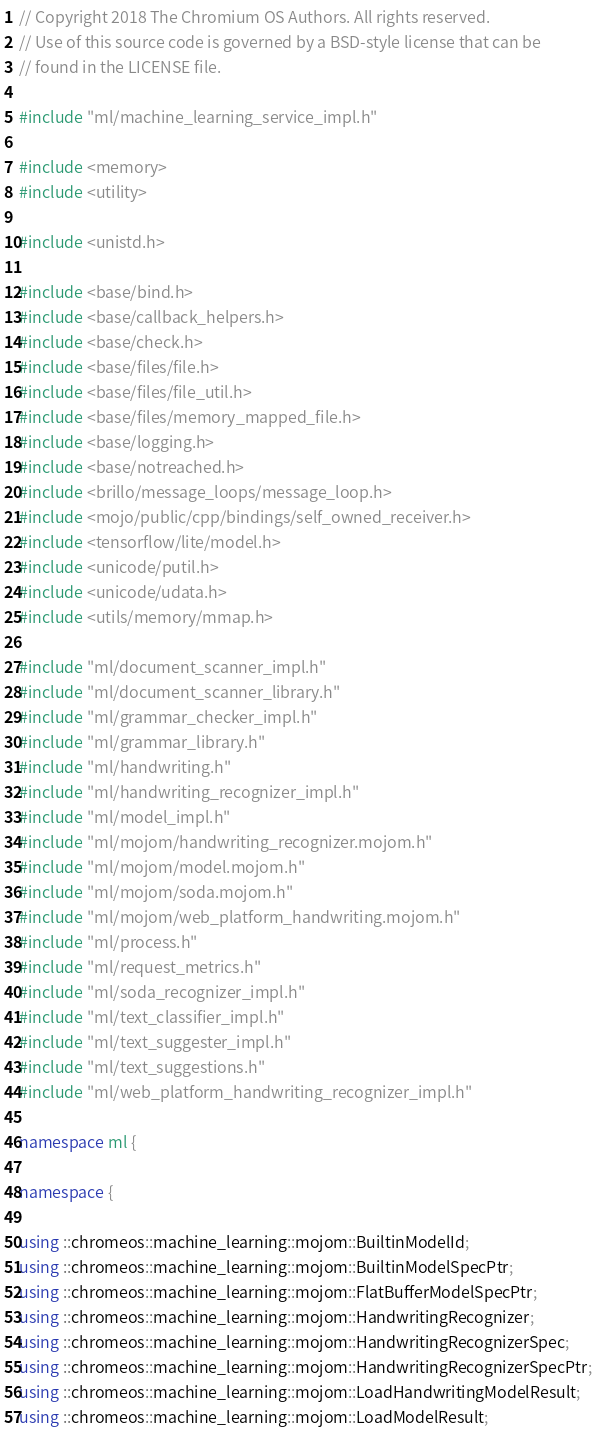Convert code to text. <code><loc_0><loc_0><loc_500><loc_500><_C++_>// Copyright 2018 The Chromium OS Authors. All rights reserved.
// Use of this source code is governed by a BSD-style license that can be
// found in the LICENSE file.

#include "ml/machine_learning_service_impl.h"

#include <memory>
#include <utility>

#include <unistd.h>

#include <base/bind.h>
#include <base/callback_helpers.h>
#include <base/check.h>
#include <base/files/file.h>
#include <base/files/file_util.h>
#include <base/files/memory_mapped_file.h>
#include <base/logging.h>
#include <base/notreached.h>
#include <brillo/message_loops/message_loop.h>
#include <mojo/public/cpp/bindings/self_owned_receiver.h>
#include <tensorflow/lite/model.h>
#include <unicode/putil.h>
#include <unicode/udata.h>
#include <utils/memory/mmap.h>

#include "ml/document_scanner_impl.h"
#include "ml/document_scanner_library.h"
#include "ml/grammar_checker_impl.h"
#include "ml/grammar_library.h"
#include "ml/handwriting.h"
#include "ml/handwriting_recognizer_impl.h"
#include "ml/model_impl.h"
#include "ml/mojom/handwriting_recognizer.mojom.h"
#include "ml/mojom/model.mojom.h"
#include "ml/mojom/soda.mojom.h"
#include "ml/mojom/web_platform_handwriting.mojom.h"
#include "ml/process.h"
#include "ml/request_metrics.h"
#include "ml/soda_recognizer_impl.h"
#include "ml/text_classifier_impl.h"
#include "ml/text_suggester_impl.h"
#include "ml/text_suggestions.h"
#include "ml/web_platform_handwriting_recognizer_impl.h"

namespace ml {

namespace {

using ::chromeos::machine_learning::mojom::BuiltinModelId;
using ::chromeos::machine_learning::mojom::BuiltinModelSpecPtr;
using ::chromeos::machine_learning::mojom::FlatBufferModelSpecPtr;
using ::chromeos::machine_learning::mojom::HandwritingRecognizer;
using ::chromeos::machine_learning::mojom::HandwritingRecognizerSpec;
using ::chromeos::machine_learning::mojom::HandwritingRecognizerSpecPtr;
using ::chromeos::machine_learning::mojom::LoadHandwritingModelResult;
using ::chromeos::machine_learning::mojom::LoadModelResult;</code> 